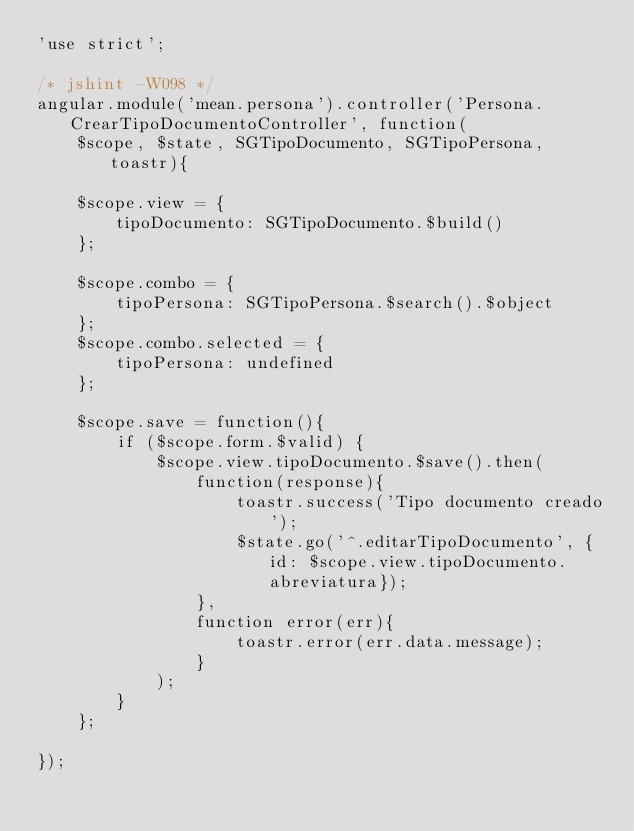<code> <loc_0><loc_0><loc_500><loc_500><_JavaScript_>'use strict';

/* jshint -W098 */
angular.module('mean.persona').controller('Persona.CrearTipoDocumentoController', function(
    $scope, $state, SGTipoDocumento, SGTipoPersona, toastr){

    $scope.view = {
        tipoDocumento: SGTipoDocumento.$build()
    };

    $scope.combo = {
        tipoPersona: SGTipoPersona.$search().$object
    };
    $scope.combo.selected = {
        tipoPersona: undefined
    };

    $scope.save = function(){
        if ($scope.form.$valid) {
            $scope.view.tipoDocumento.$save().then(
                function(response){
                    toastr.success('Tipo documento creado');
                    $state.go('^.editarTipoDocumento', {id: $scope.view.tipoDocumento.abreviatura});
                },
                function error(err){
                    toastr.error(err.data.message);
                }
            );
        }
    };

});
       </code> 